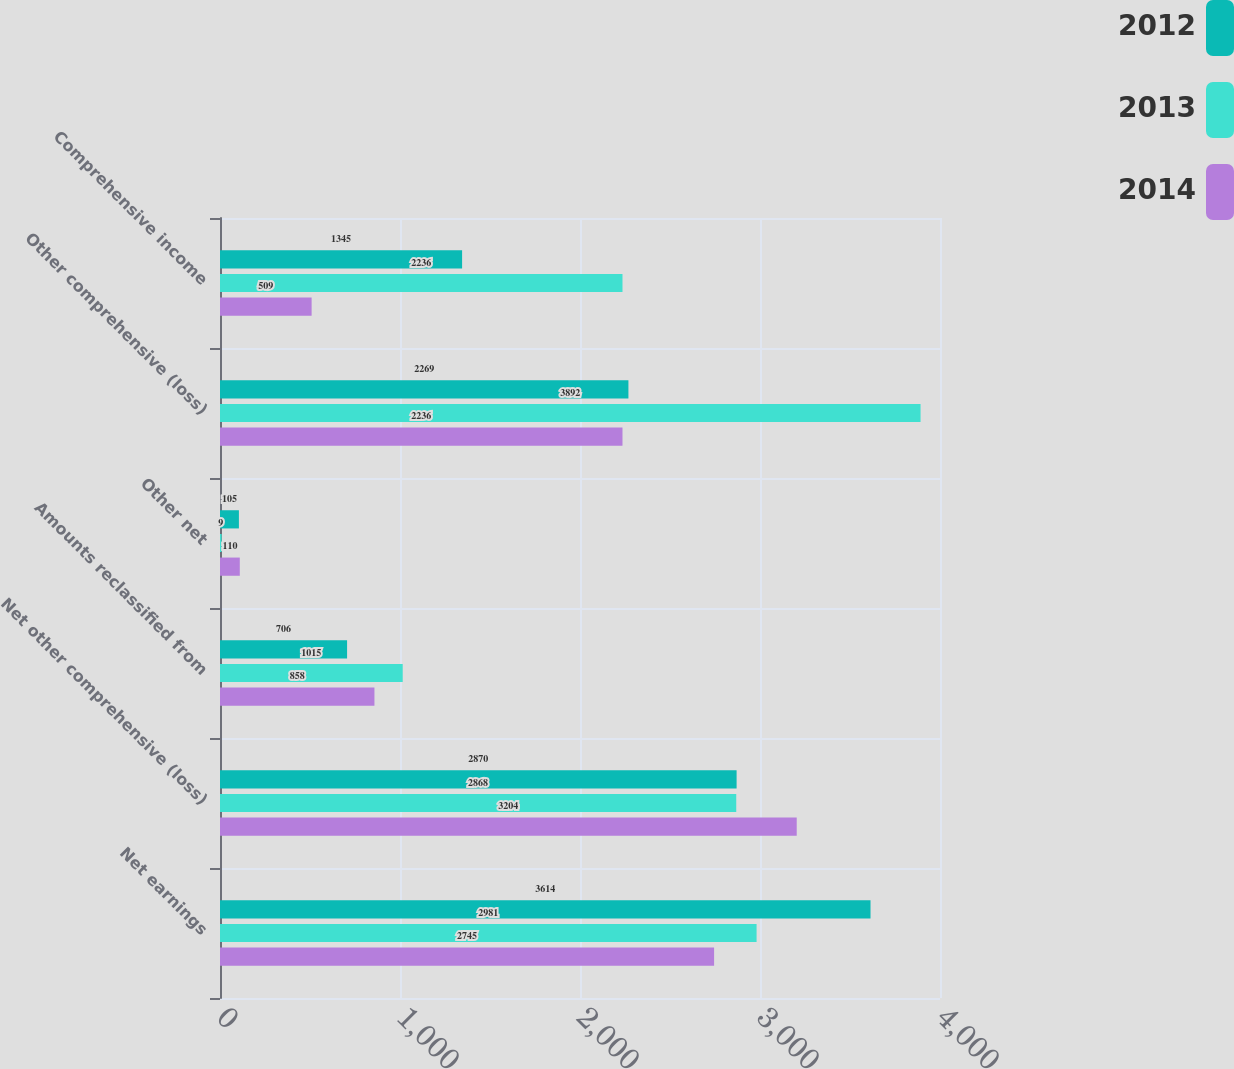Convert chart to OTSL. <chart><loc_0><loc_0><loc_500><loc_500><stacked_bar_chart><ecel><fcel>Net earnings<fcel>Net other comprehensive (loss)<fcel>Amounts reclassified from<fcel>Other net<fcel>Other comprehensive (loss)<fcel>Comprehensive income<nl><fcel>2012<fcel>3614<fcel>2870<fcel>706<fcel>105<fcel>2269<fcel>1345<nl><fcel>2013<fcel>2981<fcel>2868<fcel>1015<fcel>9<fcel>3892<fcel>2236<nl><fcel>2014<fcel>2745<fcel>3204<fcel>858<fcel>110<fcel>2236<fcel>509<nl></chart> 